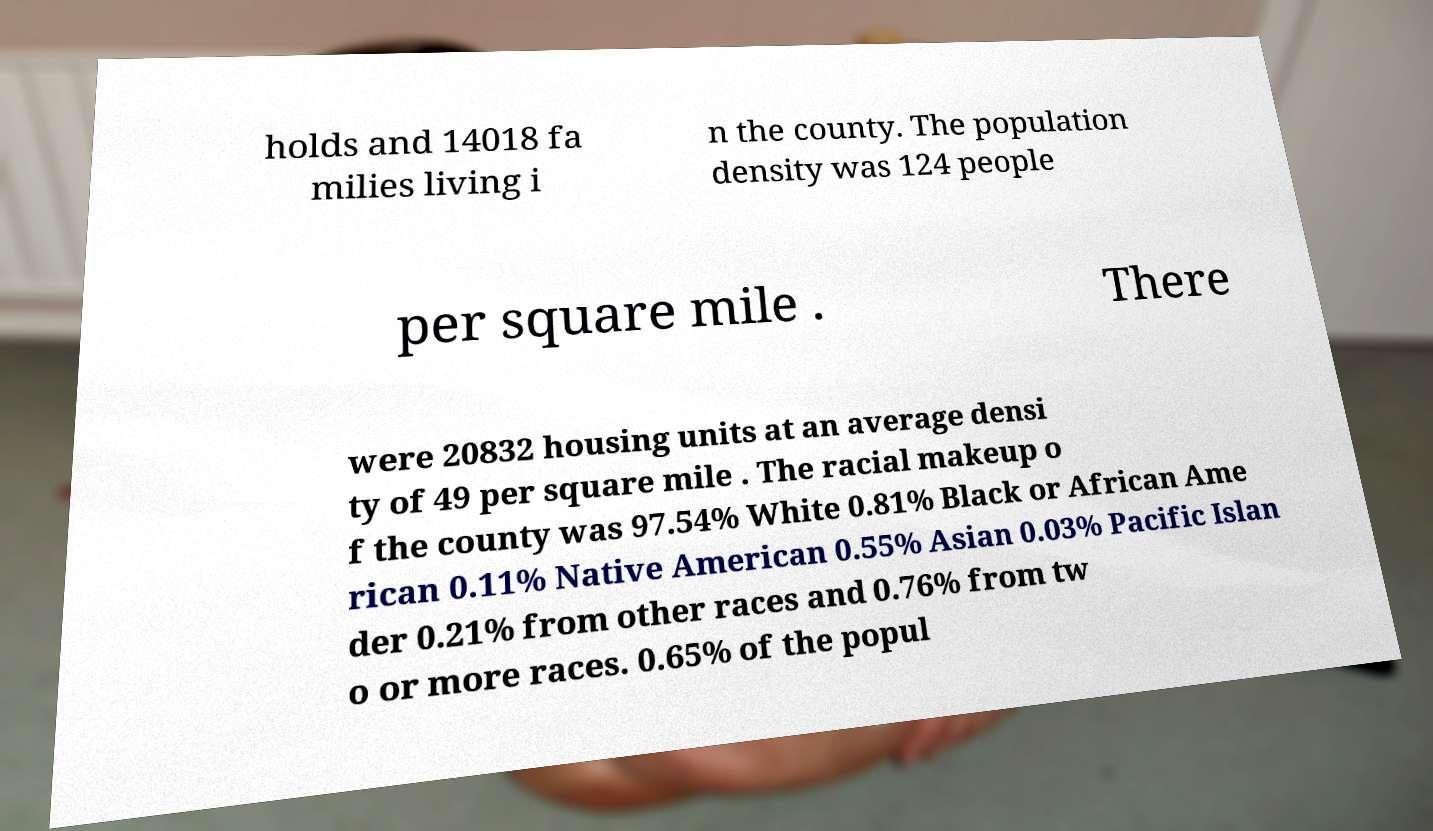Could you assist in decoding the text presented in this image and type it out clearly? holds and 14018 fa milies living i n the county. The population density was 124 people per square mile . There were 20832 housing units at an average densi ty of 49 per square mile . The racial makeup o f the county was 97.54% White 0.81% Black or African Ame rican 0.11% Native American 0.55% Asian 0.03% Pacific Islan der 0.21% from other races and 0.76% from tw o or more races. 0.65% of the popul 